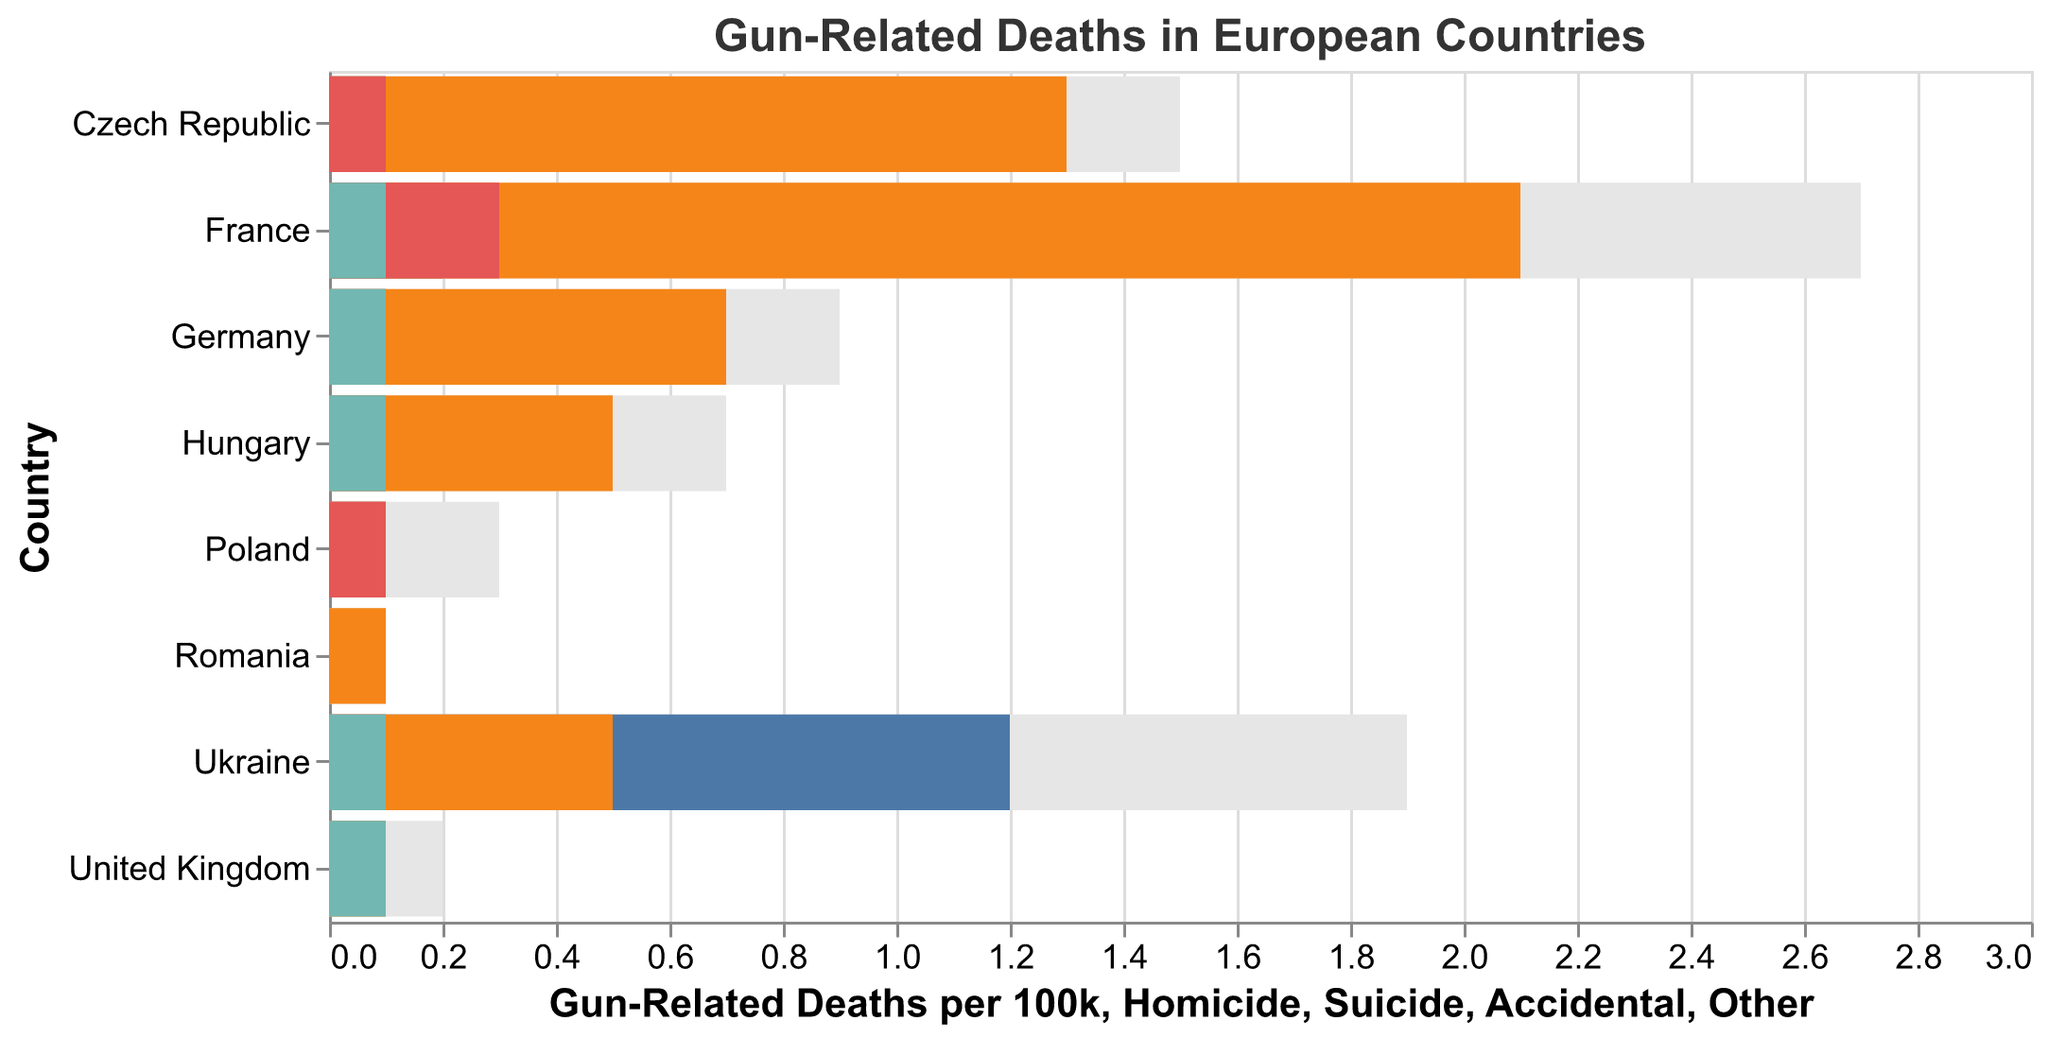What is the total number of gun-related deaths per 100k in Ukraine? Look at the bar representing Ukraine. The height of the bar indicates the total number of gun-related deaths per 100k, which is 1.9
Answer: 1.9 Which country has the highest total gun-related deaths per 100k? Among all the bars representing each country, the bar for France is the tallest, indicating the highest total gun-related deaths per 100k, which is 2.7
Answer: France How do the rates of homicide gun-related deaths compare between Ukraine and France? In the figure, Ukraine's homicide rate is 1.2 per 100k while France's rate is 0.2 per 100k. To compare them, note that 1.2 (Ukraine) is greater than 0.2 (France)
Answer: Ukraine has a higher rate What is the combined rate of homicide and suicide gun-related deaths in Germany? For Germany, the homicide rate is 0.1 and the suicide rate is 0.7. Adding these together gives 0.1 + 0.7 = 0.8
Answer: 0.8 Which country has the lowest rate of suicide gun-related deaths? By examining the bars colored for 'Suicide', Romania has the smallest bar with a rate of 0.1, which is the lowest among all countries
Answer: Romania Which type of gun-related incident contributes most to the total in France? In the chart for France, the bar color-coded for 'Suicide' extends the farthest, with a value of 2.1, indicating that suicides are the major contributing factor.
Answer: Suicide What is the difference in the rate of total gun-related deaths per 100k between Ukraine and Poland? Ukraine's rate is 1.9 and Poland's rate is 0.3. The difference is calculated as 1.9 - 0.3 = 1.6
Answer: 1.6 Which country has an equal rate of accidental and other gun-related deaths? Examining the bars for each country, Poland has both accidental and other gun-related death rates as 0.1 and 0.0, respectively, showing equality (accidental = other)
Answer: Poland 